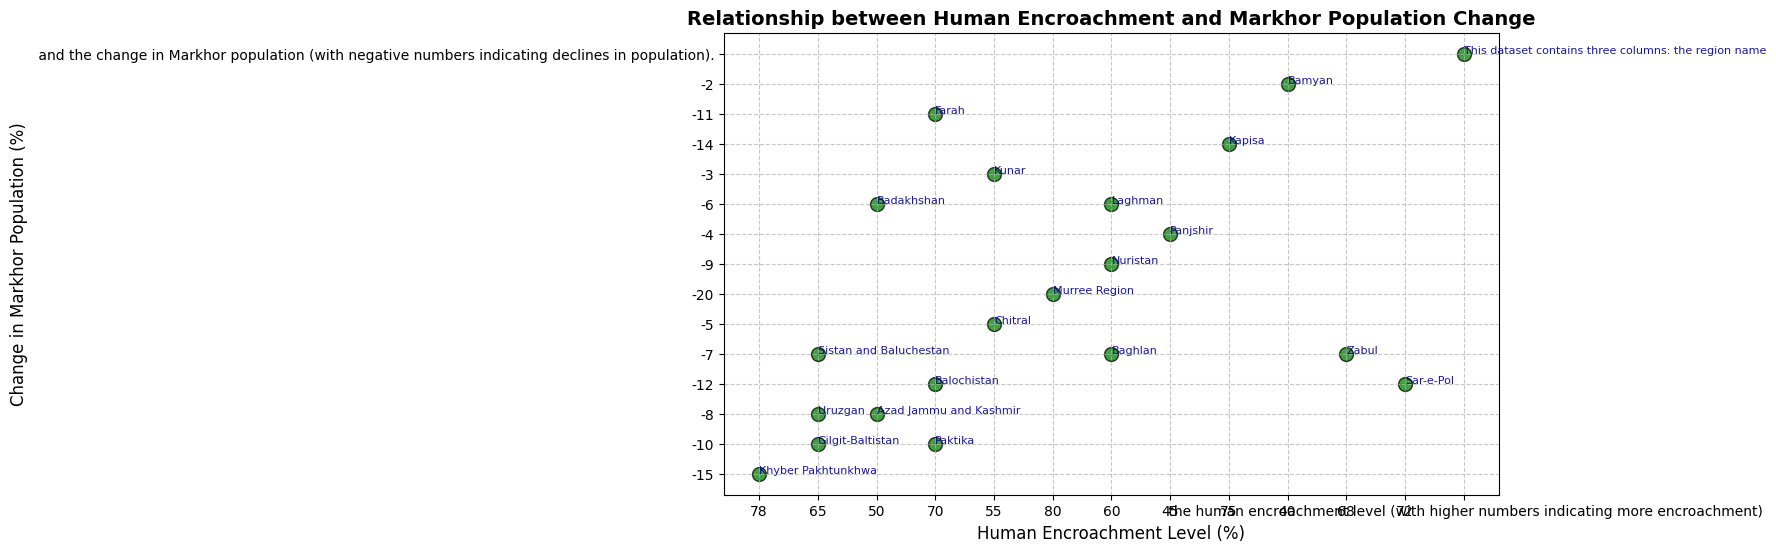What is the relationship between human encroachment levels and Markhor population change? By looking at the scatter plot, as the human encroachment level increases, the decline in the Markhor population tends to be more pronounced, suggesting a negative relationship.
Answer: Negative correlation Which region has the highest human encroachment level and how much has its Markhor population declined? The Murree Region has the highest human encroachment level at 80%, and its Markhor population has declined by 20%.
Answer: Murree Region; 20% Which regions have the least and the most change in Markhor population? The region with the least change in the Markhor population is Bamyan with a population change of -2%. The region with the most change is the Murree Region with a population change of -20%.
Answer: Bamyan; Murree Region What is the median human encroachment level among all the regions? To find the median, we arrange the human encroachment levels in ascending order [40, 45, 50, 50, 55, 55, 60, 60, 60, 65, 65, 65, 68, 70, 70, 72, 75, 78, 80] and find the middle value. The median value is 65%.
Answer: 65% Compare the Markhor population change between the regions with 70% human encroachment. The regions with 70% human encroachment are Balochistan, Farah, and Paktika. Their changes in Markhor population are -12%, -11%, and -10%, respectively.
Answer: Balochistan: -12%, Farah: -11%, Paktika: -10% Which region has the closest Markhor population change to Kunar? Kunar has a Markhor population change of -3%. The region with the closest population change is Panjshir, which has a population change of -4%.
Answer: Panjshir What is the average decline in Markhor population for regions with human encroachment levels greater than 60%? Regions with human encroachment levels greater than 60% are Khyber Pakhtunkhwa (-15%), Murree Region (-20%), Kapisa (-14%), Balochistan (-12%), Farah (-11%), Paktika (-10%), and Sar-e-Pol (-12%). Average decline = (-15 + -20 + -14 + -12 + -11 + -10 + -12) / 7 = -13.43%.
Answer: -13.43% Compare the Markhor population changes between Gilgit-Baltistan and Nuristan. Gilgit-Baltistan has a Markhor population change of -10%, while Nuristan has a population change of -9%.
Answer: Gilgit-Baltistan: -10%, Nuristan: -9% Identify all regions with human encroachment levels less than 60% and their corresponding changes in Markhor population. The regions with less than 60% human encroachment levels are Panjshir (-4%), Bamyan (-2%), Azad Jammu and Kashmir (-8%), Badakhshan (-6%), and Chitral (-5%).
Answer: Panjshir: -4%, Bamyan: -2%, Azad Jammu and Kashmir: -8%, Badakhshan: -6%, Chitral: -5% 